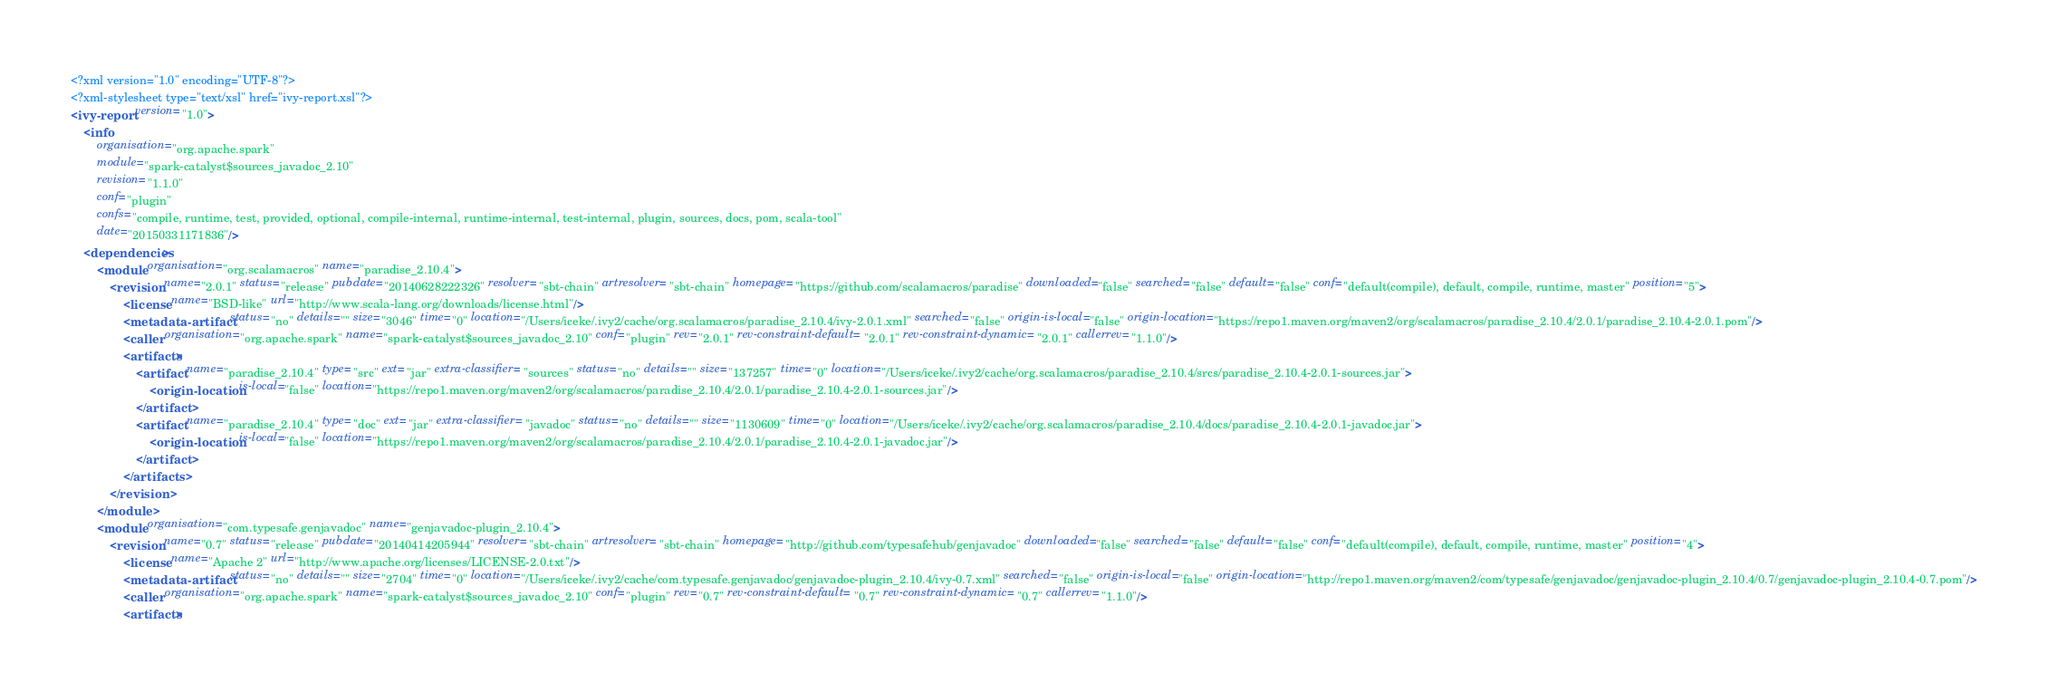<code> <loc_0><loc_0><loc_500><loc_500><_XML_><?xml version="1.0" encoding="UTF-8"?>
<?xml-stylesheet type="text/xsl" href="ivy-report.xsl"?>
<ivy-report version="1.0">
	<info
		organisation="org.apache.spark"
		module="spark-catalyst$sources_javadoc_2.10"
		revision="1.1.0"
		conf="plugin"
		confs="compile, runtime, test, provided, optional, compile-internal, runtime-internal, test-internal, plugin, sources, docs, pom, scala-tool"
		date="20150331171836"/>
	<dependencies>
		<module organisation="org.scalamacros" name="paradise_2.10.4">
			<revision name="2.0.1" status="release" pubdate="20140628222326" resolver="sbt-chain" artresolver="sbt-chain" homepage="https://github.com/scalamacros/paradise" downloaded="false" searched="false" default="false" conf="default(compile), default, compile, runtime, master" position="5">
				<license name="BSD-like" url="http://www.scala-lang.org/downloads/license.html"/>
				<metadata-artifact status="no" details="" size="3046" time="0" location="/Users/iceke/.ivy2/cache/org.scalamacros/paradise_2.10.4/ivy-2.0.1.xml" searched="false" origin-is-local="false" origin-location="https://repo1.maven.org/maven2/org/scalamacros/paradise_2.10.4/2.0.1/paradise_2.10.4-2.0.1.pom"/>
				<caller organisation="org.apache.spark" name="spark-catalyst$sources_javadoc_2.10" conf="plugin" rev="2.0.1" rev-constraint-default="2.0.1" rev-constraint-dynamic="2.0.1" callerrev="1.1.0"/>
				<artifacts>
					<artifact name="paradise_2.10.4" type="src" ext="jar" extra-classifier="sources" status="no" details="" size="137257" time="0" location="/Users/iceke/.ivy2/cache/org.scalamacros/paradise_2.10.4/srcs/paradise_2.10.4-2.0.1-sources.jar">
						<origin-location is-local="false" location="https://repo1.maven.org/maven2/org/scalamacros/paradise_2.10.4/2.0.1/paradise_2.10.4-2.0.1-sources.jar"/>
					</artifact>
					<artifact name="paradise_2.10.4" type="doc" ext="jar" extra-classifier="javadoc" status="no" details="" size="1130609" time="0" location="/Users/iceke/.ivy2/cache/org.scalamacros/paradise_2.10.4/docs/paradise_2.10.4-2.0.1-javadoc.jar">
						<origin-location is-local="false" location="https://repo1.maven.org/maven2/org/scalamacros/paradise_2.10.4/2.0.1/paradise_2.10.4-2.0.1-javadoc.jar"/>
					</artifact>
				</artifacts>
			</revision>
		</module>
		<module organisation="com.typesafe.genjavadoc" name="genjavadoc-plugin_2.10.4">
			<revision name="0.7" status="release" pubdate="20140414205944" resolver="sbt-chain" artresolver="sbt-chain" homepage="http://github.com/typesafehub/genjavadoc" downloaded="false" searched="false" default="false" conf="default(compile), default, compile, runtime, master" position="4">
				<license name="Apache 2" url="http://www.apache.org/licenses/LICENSE-2.0.txt"/>
				<metadata-artifact status="no" details="" size="2704" time="0" location="/Users/iceke/.ivy2/cache/com.typesafe.genjavadoc/genjavadoc-plugin_2.10.4/ivy-0.7.xml" searched="false" origin-is-local="false" origin-location="http://repo1.maven.org/maven2/com/typesafe/genjavadoc/genjavadoc-plugin_2.10.4/0.7/genjavadoc-plugin_2.10.4-0.7.pom"/>
				<caller organisation="org.apache.spark" name="spark-catalyst$sources_javadoc_2.10" conf="plugin" rev="0.7" rev-constraint-default="0.7" rev-constraint-dynamic="0.7" callerrev="1.1.0"/>
				<artifacts></code> 